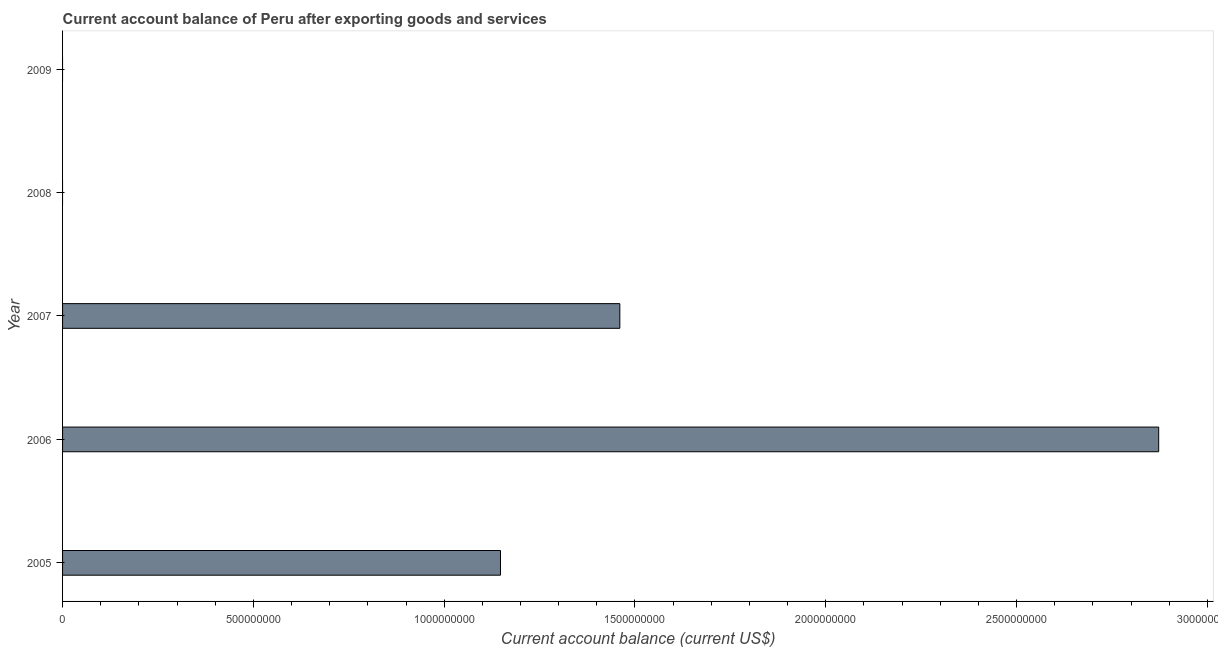Does the graph contain any zero values?
Your answer should be very brief. Yes. What is the title of the graph?
Give a very brief answer. Current account balance of Peru after exporting goods and services. What is the label or title of the X-axis?
Your answer should be very brief. Current account balance (current US$). What is the label or title of the Y-axis?
Offer a very short reply. Year. What is the current account balance in 2005?
Give a very brief answer. 1.15e+09. Across all years, what is the maximum current account balance?
Your response must be concise. 2.87e+09. What is the sum of the current account balance?
Ensure brevity in your answer.  5.48e+09. What is the difference between the current account balance in 2006 and 2007?
Keep it short and to the point. 1.41e+09. What is the average current account balance per year?
Ensure brevity in your answer.  1.10e+09. What is the median current account balance?
Offer a very short reply. 1.15e+09. In how many years, is the current account balance greater than 1300000000 US$?
Give a very brief answer. 2. What is the ratio of the current account balance in 2005 to that in 2007?
Ensure brevity in your answer.  0.79. Is the difference between the current account balance in 2006 and 2007 greater than the difference between any two years?
Your answer should be very brief. No. What is the difference between the highest and the second highest current account balance?
Your response must be concise. 1.41e+09. What is the difference between the highest and the lowest current account balance?
Give a very brief answer. 2.87e+09. Are all the bars in the graph horizontal?
Your response must be concise. Yes. What is the difference between two consecutive major ticks on the X-axis?
Keep it short and to the point. 5.00e+08. Are the values on the major ticks of X-axis written in scientific E-notation?
Your answer should be very brief. No. What is the Current account balance (current US$) in 2005?
Provide a succinct answer. 1.15e+09. What is the Current account balance (current US$) in 2006?
Ensure brevity in your answer.  2.87e+09. What is the Current account balance (current US$) of 2007?
Give a very brief answer. 1.46e+09. What is the difference between the Current account balance (current US$) in 2005 and 2006?
Provide a succinct answer. -1.72e+09. What is the difference between the Current account balance (current US$) in 2005 and 2007?
Provide a succinct answer. -3.13e+08. What is the difference between the Current account balance (current US$) in 2006 and 2007?
Keep it short and to the point. 1.41e+09. What is the ratio of the Current account balance (current US$) in 2005 to that in 2006?
Keep it short and to the point. 0.4. What is the ratio of the Current account balance (current US$) in 2005 to that in 2007?
Offer a very short reply. 0.79. What is the ratio of the Current account balance (current US$) in 2006 to that in 2007?
Keep it short and to the point. 1.97. 